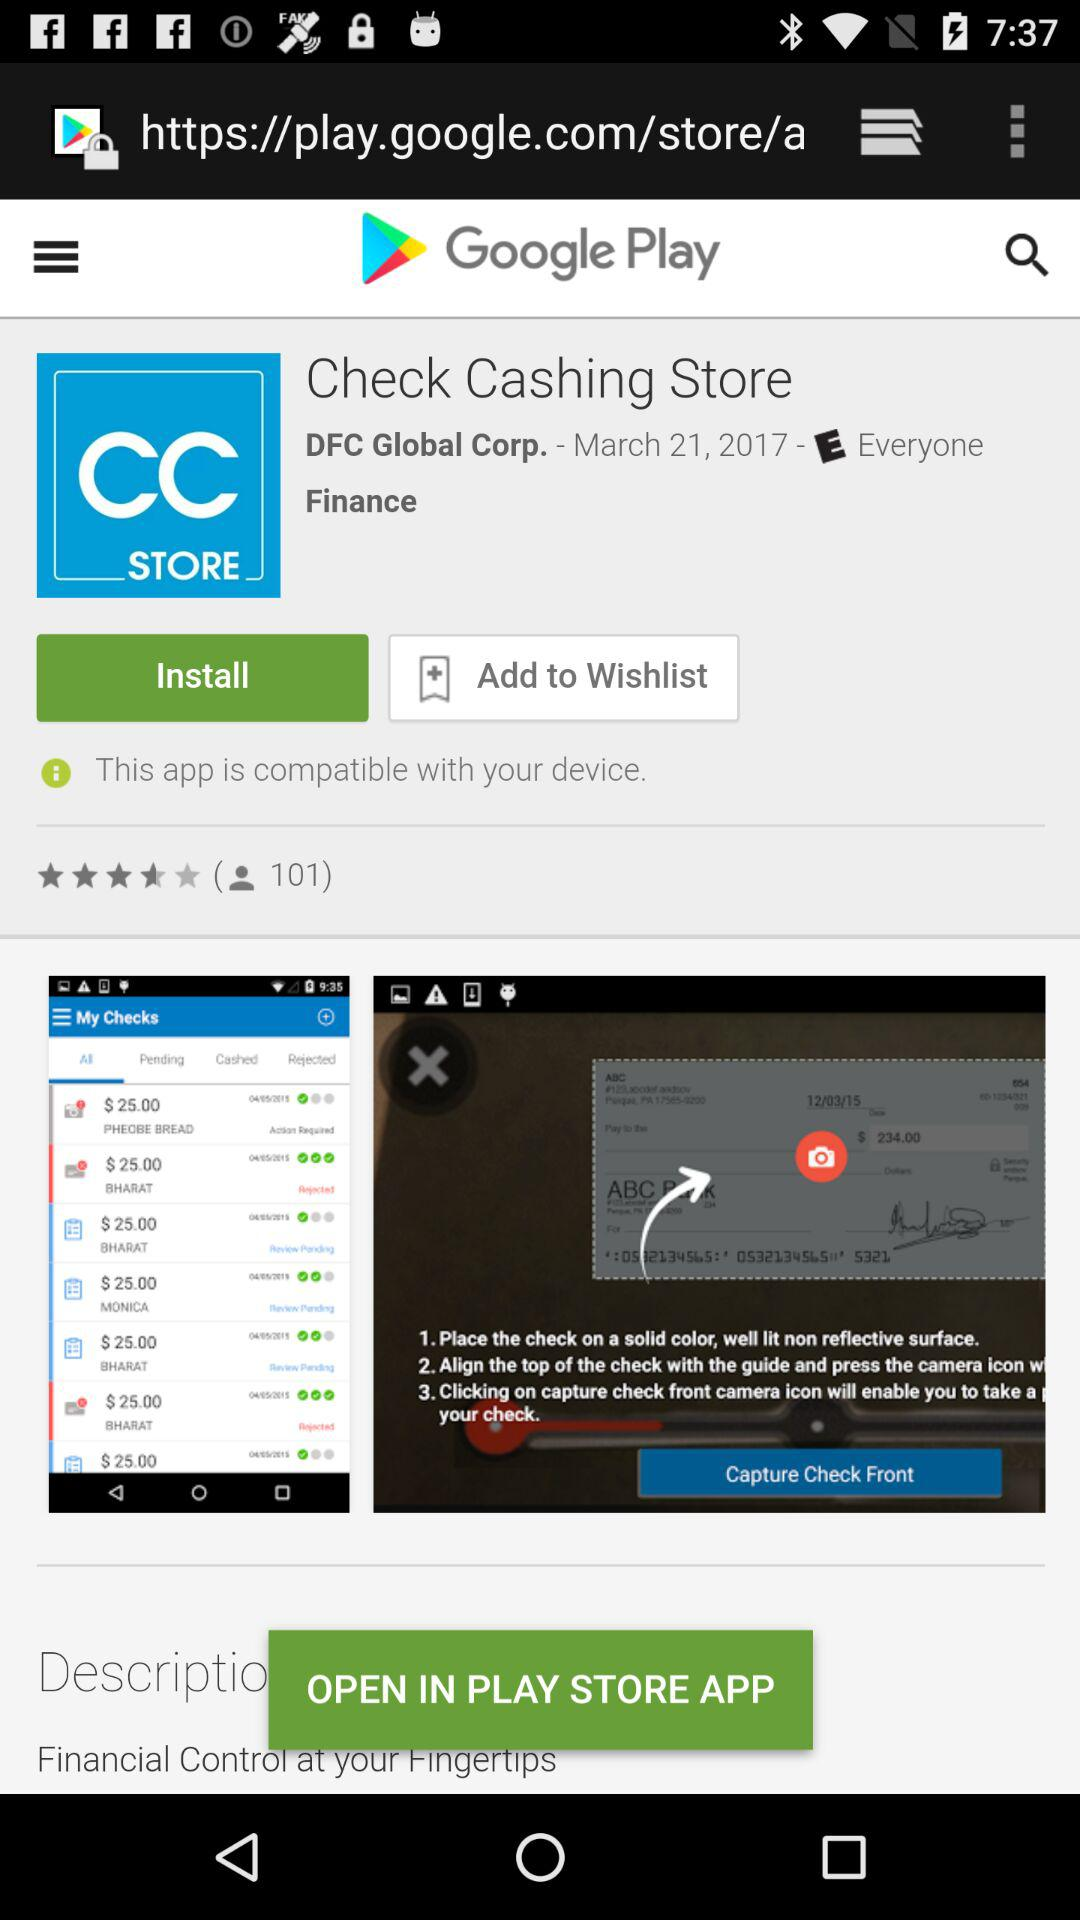On which date application Check Cashing Store is updated?
When the provided information is insufficient, respond with <no answer>. <no answer> 